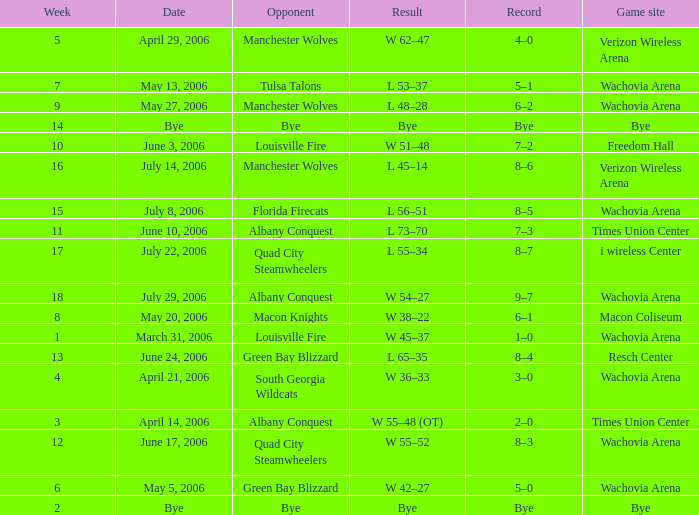What is the Game site week 1? Wachovia Arena. 